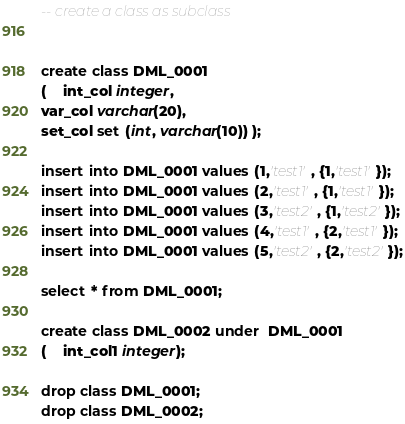<code> <loc_0><loc_0><loc_500><loc_500><_SQL_>-- create a class as subclass


create class DML_0001 
( 	int_col integer,
var_col varchar(20),
set_col set (int, varchar(10)) );

insert into DML_0001 values (1,'test1', {1,'test1'});
insert into DML_0001 values (2,'test1', {1,'test1'});
insert into DML_0001 values (3,'test2', {1,'test2'});
insert into DML_0001 values (4,'test1', {2,'test1'});
insert into DML_0001 values (5,'test2', {2,'test2'});

select * from DML_0001;

create class DML_0002 under  DML_0001
( 	int_col1 integer);

drop class DML_0001;
drop class DML_0002;
</code> 